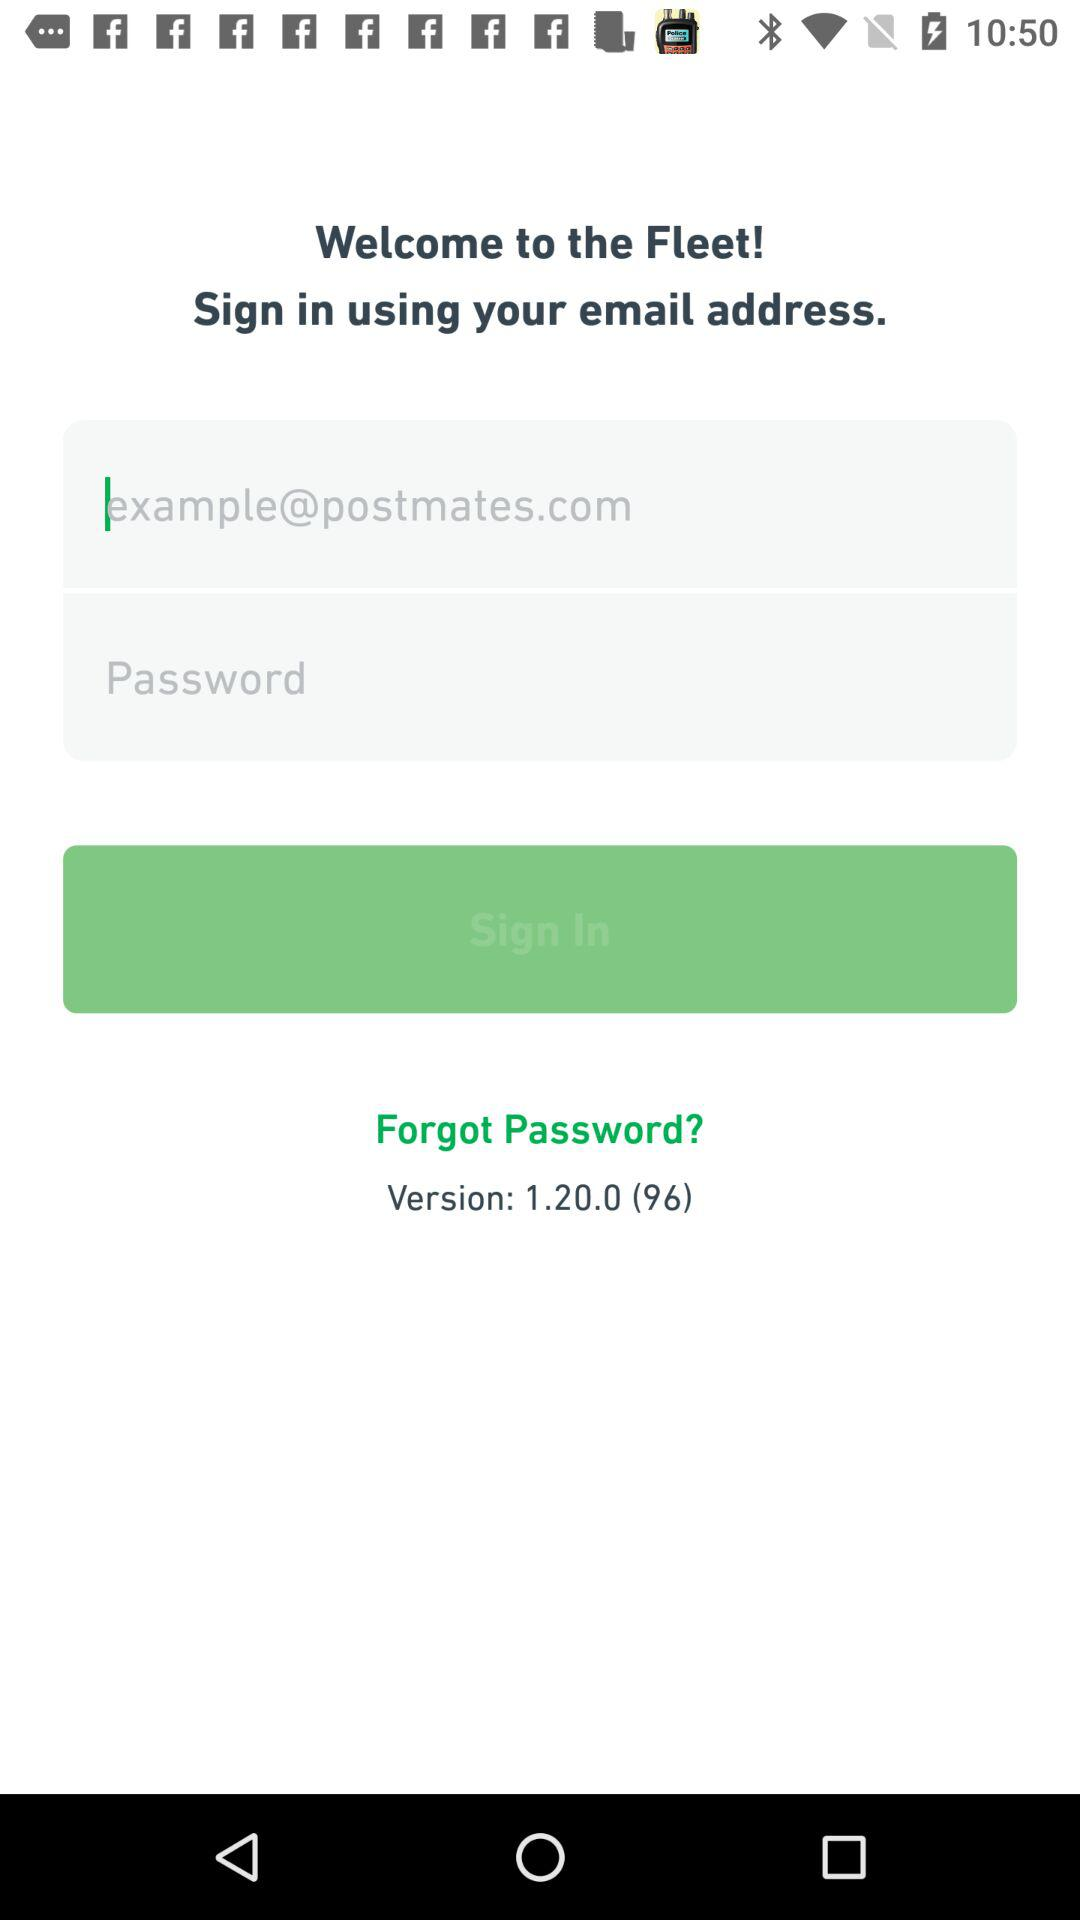What is the version of the application? The version is 1.20.0 (96). 